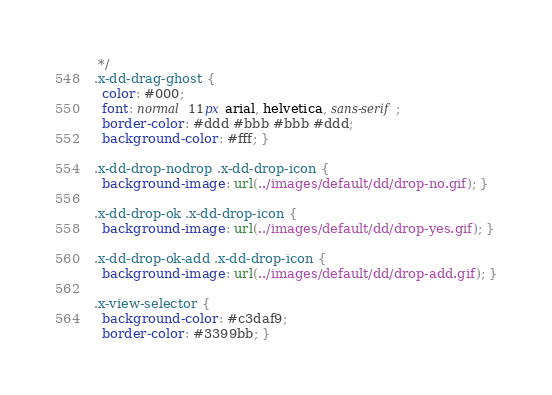<code> <loc_0><loc_0><loc_500><loc_500><_CSS_> */
.x-dd-drag-ghost {
  color: #000;
  font: normal 11px arial, helvetica, sans-serif;
  border-color: #ddd #bbb #bbb #ddd;
  background-color: #fff; }

.x-dd-drop-nodrop .x-dd-drop-icon {
  background-image: url(../images/default/dd/drop-no.gif); }

.x-dd-drop-ok .x-dd-drop-icon {
  background-image: url(../images/default/dd/drop-yes.gif); }

.x-dd-drop-ok-add .x-dd-drop-icon {
  background-image: url(../images/default/dd/drop-add.gif); }

.x-view-selector {
  background-color: #c3daf9;
  border-color: #3399bb; }

</code> 